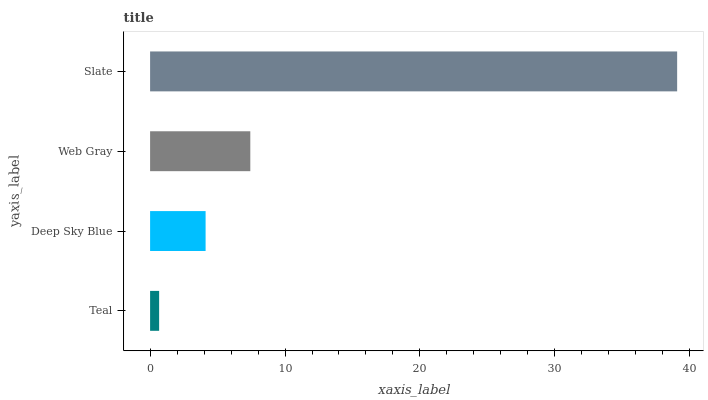Is Teal the minimum?
Answer yes or no. Yes. Is Slate the maximum?
Answer yes or no. Yes. Is Deep Sky Blue the minimum?
Answer yes or no. No. Is Deep Sky Blue the maximum?
Answer yes or no. No. Is Deep Sky Blue greater than Teal?
Answer yes or no. Yes. Is Teal less than Deep Sky Blue?
Answer yes or no. Yes. Is Teal greater than Deep Sky Blue?
Answer yes or no. No. Is Deep Sky Blue less than Teal?
Answer yes or no. No. Is Web Gray the high median?
Answer yes or no. Yes. Is Deep Sky Blue the low median?
Answer yes or no. Yes. Is Deep Sky Blue the high median?
Answer yes or no. No. Is Slate the low median?
Answer yes or no. No. 